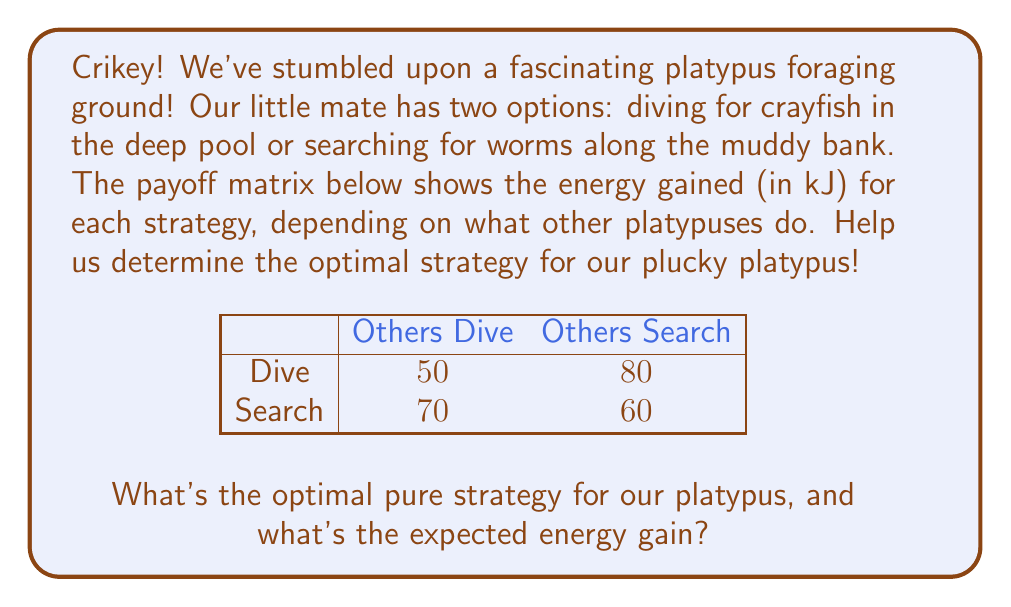What is the answer to this math problem? Let's tackle this problem using game theory, mates!

1) First, we need to check if there's a dominant strategy. A strategy is dominant if it's always better, regardless of what others do.

   For Dive: 50 < 70 (when others dive), 80 > 60 (when others search)
   For Search: 70 > 50 (when others dive), 60 < 80 (when others search)

   There's no dominant strategy, so we need to find a mixed strategy equilibrium.

2) Let's define $p$ as the probability of diving. Then $(1-p)$ is the probability of searching.

3) For a mixed strategy equilibrium, the expected payoff of diving should equal the expected payoff of searching:

   $50p + 80(1-p) = 70p + 60(1-p)$

4) Simplify the equation:
   $50p + 80 - 80p = 70p + 60 - 60p$
   $-30p + 80 = 10p + 60$
   $-40p = -20$
   $p = \frac{1}{2} = 0.5$

5) This means our platypus should dive 50% of the time and search 50% of the time.

6) To calculate the expected energy gain, we can use either strategy's payoff (as they're equal in equilibrium):

   $E(\text{Dive}) = 50(0.5) + 80(0.5) = 25 + 40 = 65$ kJ

Therefore, the optimal strategy is to mix diving and searching equally, with an expected energy gain of 65 kJ.
Answer: Mix 50% dive, 50% search; 65 kJ expected gain 